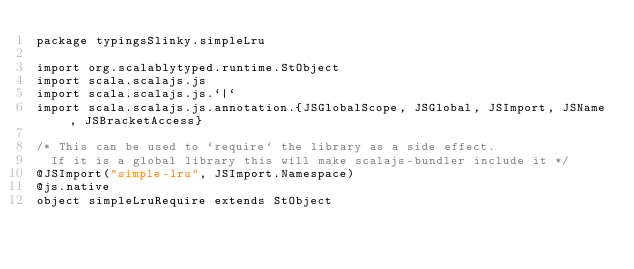<code> <loc_0><loc_0><loc_500><loc_500><_Scala_>package typingsSlinky.simpleLru

import org.scalablytyped.runtime.StObject
import scala.scalajs.js
import scala.scalajs.js.`|`
import scala.scalajs.js.annotation.{JSGlobalScope, JSGlobal, JSImport, JSName, JSBracketAccess}

/* This can be used to `require` the library as a side effect.
  If it is a global library this will make scalajs-bundler include it */
@JSImport("simple-lru", JSImport.Namespace)
@js.native
object simpleLruRequire extends StObject
</code> 